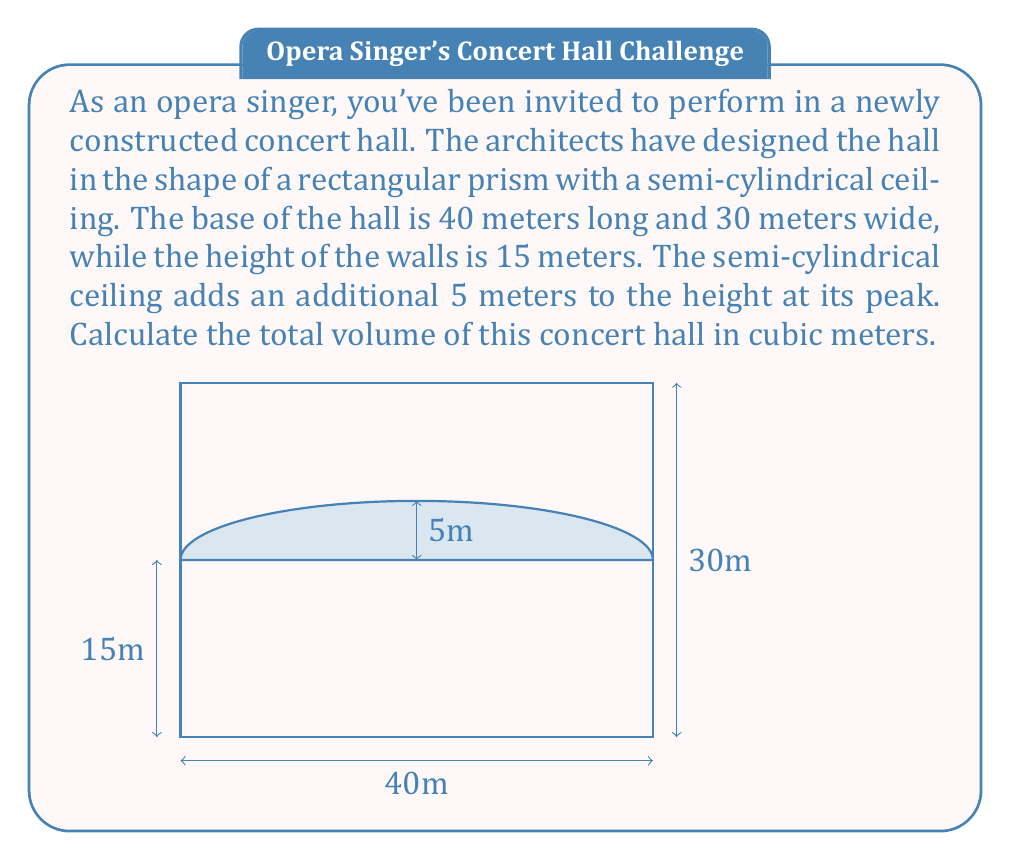Can you answer this question? To calculate the total volume of the concert hall, we need to break it down into two parts:
1. The rectangular prism base
2. The semi-cylindrical ceiling

Step 1: Calculate the volume of the rectangular prism base
- Length = 40 m, Width = 30 m, Height = 15 m
- Volume of rectangular prism = $L \times W \times H$
- $V_1 = 40 \times 30 \times 15 = 18,000$ cubic meters

Step 2: Calculate the volume of the semi-cylindrical ceiling
- The semi-cylinder has a radius of 5 m (the additional height)
- The length of the semi-cylinder is equal to the length of the hall (40 m)
- Volume of a cylinder = $\pi r^2 h$, but we only need half of this
- $V_2 = \frac{1}{2} \times \pi \times 5^2 \times 40 = 500\pi$ cubic meters

Step 3: Sum up the total volume
Total Volume = $V_1 + V_2 = 18,000 + 500\pi$ cubic meters

Step 4: Evaluate the final result
$18,000 + 500\pi \approx 19,570.80$ cubic meters
Answer: $$19,570.80 \text{ m}^3$$ 